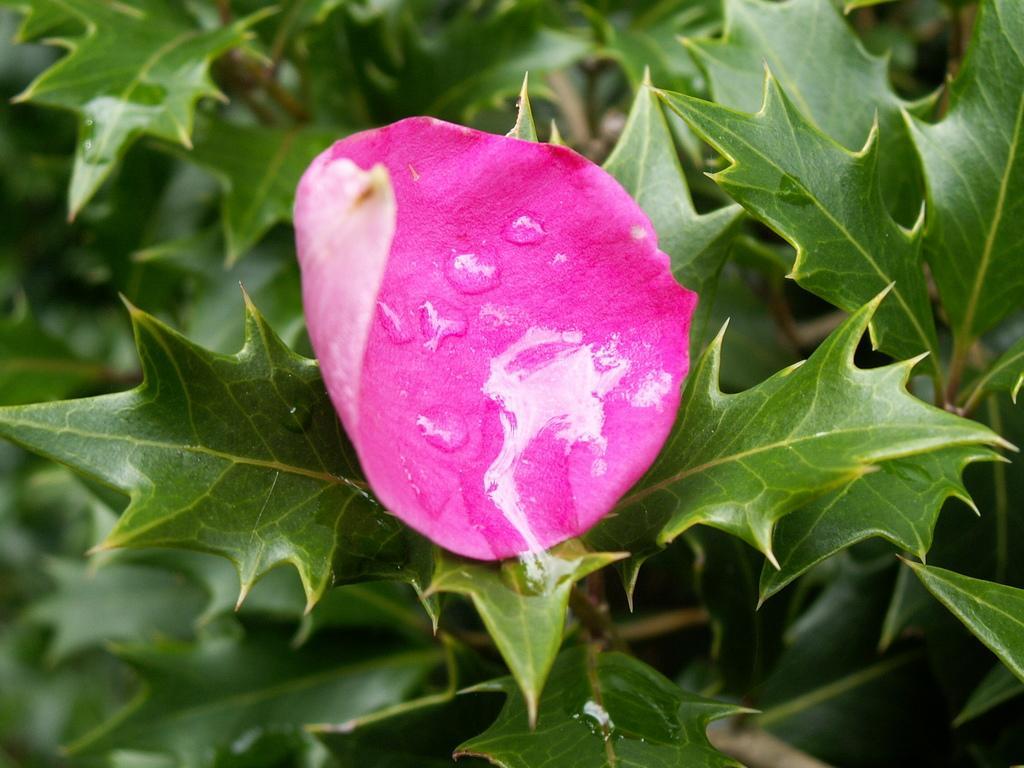Could you give a brief overview of what you see in this image? In the image we can see there is a rose petal on the plant and there are dew drops on the rose petal. 